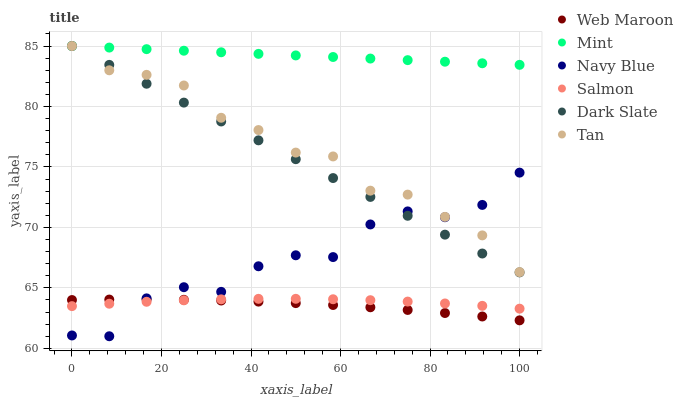Does Web Maroon have the minimum area under the curve?
Answer yes or no. Yes. Does Mint have the maximum area under the curve?
Answer yes or no. Yes. Does Salmon have the minimum area under the curve?
Answer yes or no. No. Does Salmon have the maximum area under the curve?
Answer yes or no. No. Is Dark Slate the smoothest?
Answer yes or no. Yes. Is Navy Blue the roughest?
Answer yes or no. Yes. Is Salmon the smoothest?
Answer yes or no. No. Is Salmon the roughest?
Answer yes or no. No. Does Navy Blue have the lowest value?
Answer yes or no. Yes. Does Salmon have the lowest value?
Answer yes or no. No. Does Mint have the highest value?
Answer yes or no. Yes. Does Salmon have the highest value?
Answer yes or no. No. Is Salmon less than Dark Slate?
Answer yes or no. Yes. Is Dark Slate greater than Web Maroon?
Answer yes or no. Yes. Does Dark Slate intersect Tan?
Answer yes or no. Yes. Is Dark Slate less than Tan?
Answer yes or no. No. Is Dark Slate greater than Tan?
Answer yes or no. No. Does Salmon intersect Dark Slate?
Answer yes or no. No. 